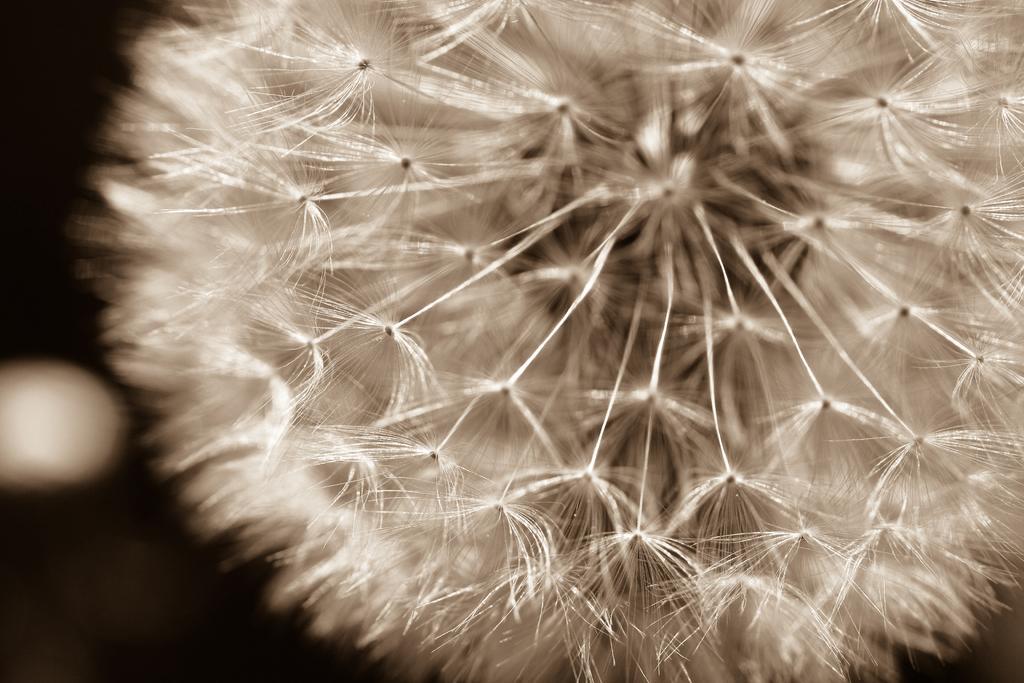Please provide a concise description of this image. In this image we can see a white color flower and the background is dark. 